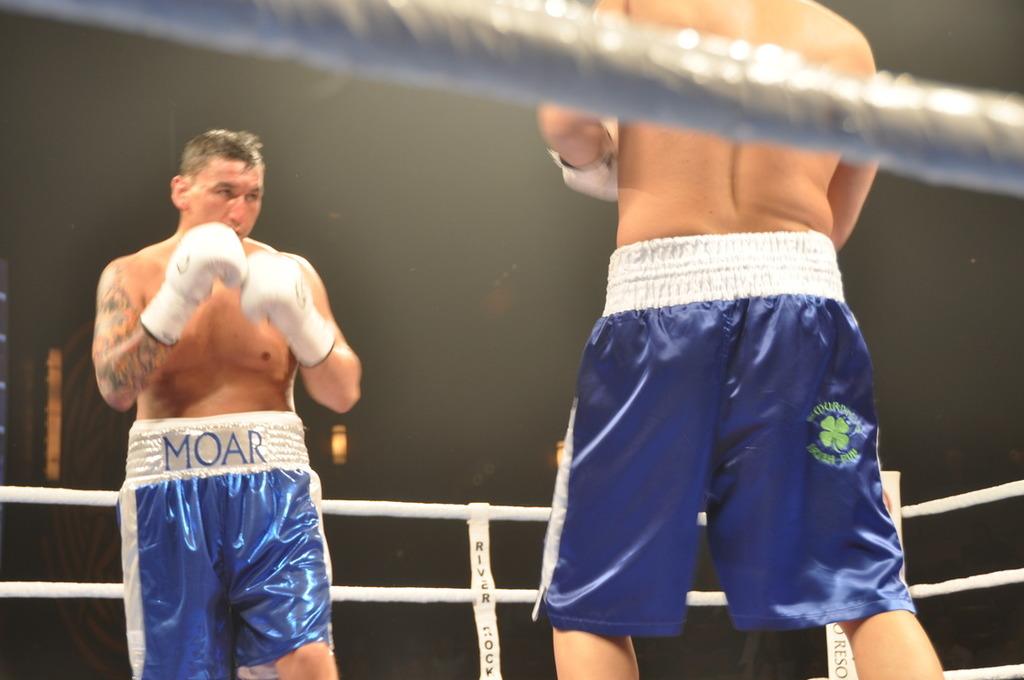What is the name on the boxers waist band?
Keep it short and to the point. Moar. 